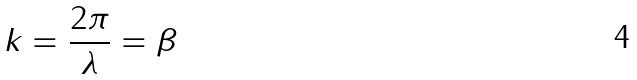<formula> <loc_0><loc_0><loc_500><loc_500>k = \frac { 2 \pi } { \lambda } = \beta</formula> 